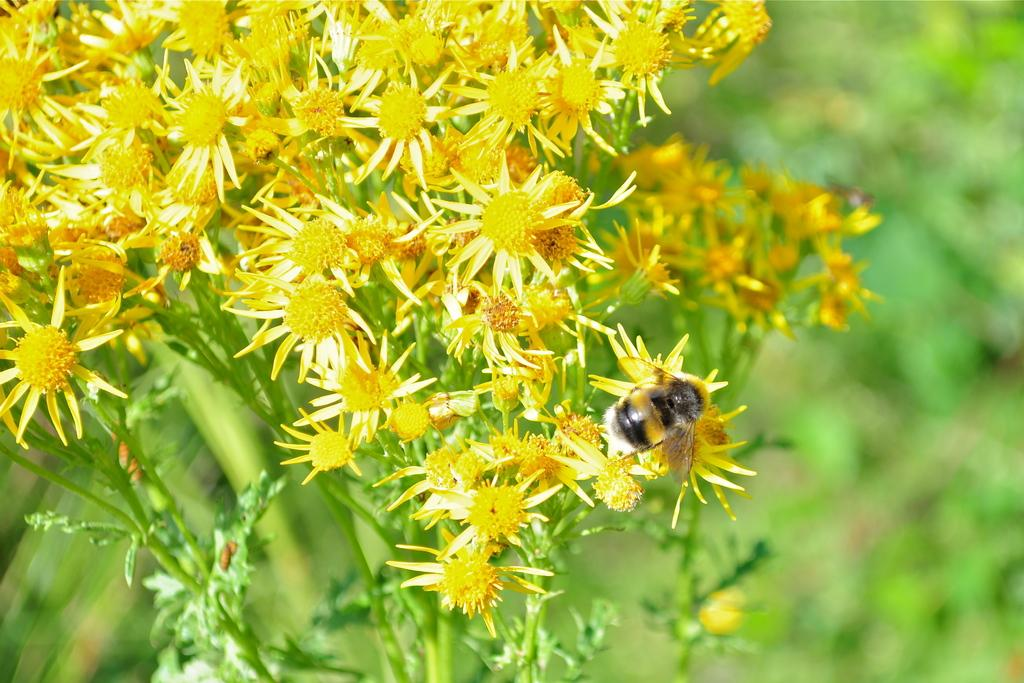Where was the image taken? The image was taken outdoors. What type of plants can be seen in the image? There are plants with yellow flowers in the image. Can you describe any living organisms present in the image? Yes, there is a honey bee on one of the flowers. What type of button is the minister wearing in the image? There is no minister or button present in the image; it features plants with yellow flowers and a honey bee. 